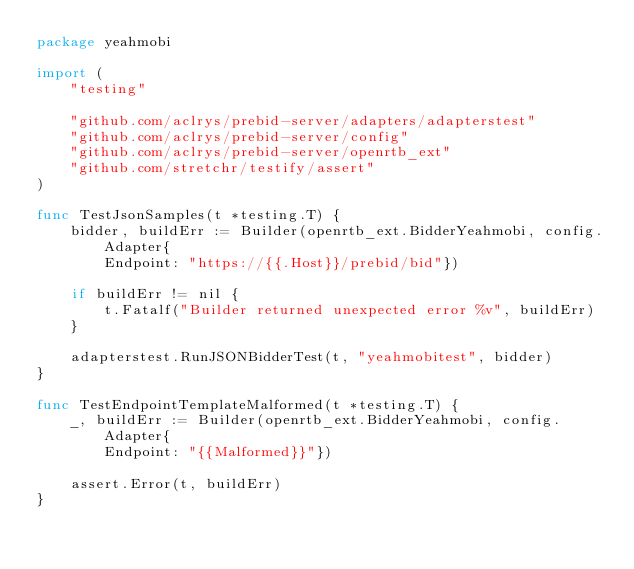<code> <loc_0><loc_0><loc_500><loc_500><_Go_>package yeahmobi

import (
	"testing"

	"github.com/aclrys/prebid-server/adapters/adapterstest"
	"github.com/aclrys/prebid-server/config"
	"github.com/aclrys/prebid-server/openrtb_ext"
	"github.com/stretchr/testify/assert"
)

func TestJsonSamples(t *testing.T) {
	bidder, buildErr := Builder(openrtb_ext.BidderYeahmobi, config.Adapter{
		Endpoint: "https://{{.Host}}/prebid/bid"})

	if buildErr != nil {
		t.Fatalf("Builder returned unexpected error %v", buildErr)
	}

	adapterstest.RunJSONBidderTest(t, "yeahmobitest", bidder)
}

func TestEndpointTemplateMalformed(t *testing.T) {
	_, buildErr := Builder(openrtb_ext.BidderYeahmobi, config.Adapter{
		Endpoint: "{{Malformed}}"})

	assert.Error(t, buildErr)
}
</code> 